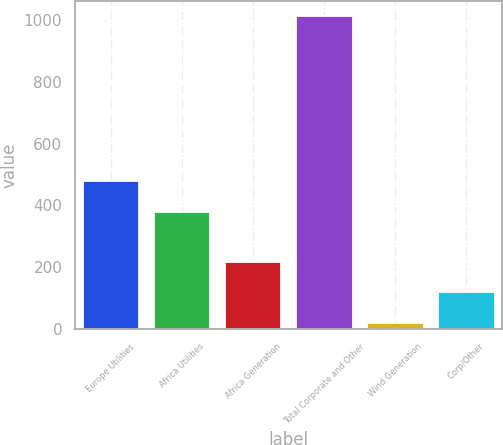<chart> <loc_0><loc_0><loc_500><loc_500><bar_chart><fcel>Europe Utilities<fcel>Africa Utilities<fcel>Africa Generation<fcel>Total Corporate and Other<fcel>Wind Generation<fcel>Corp/Other<nl><fcel>478.3<fcel>379<fcel>217.6<fcel>1012<fcel>19<fcel>118.3<nl></chart> 